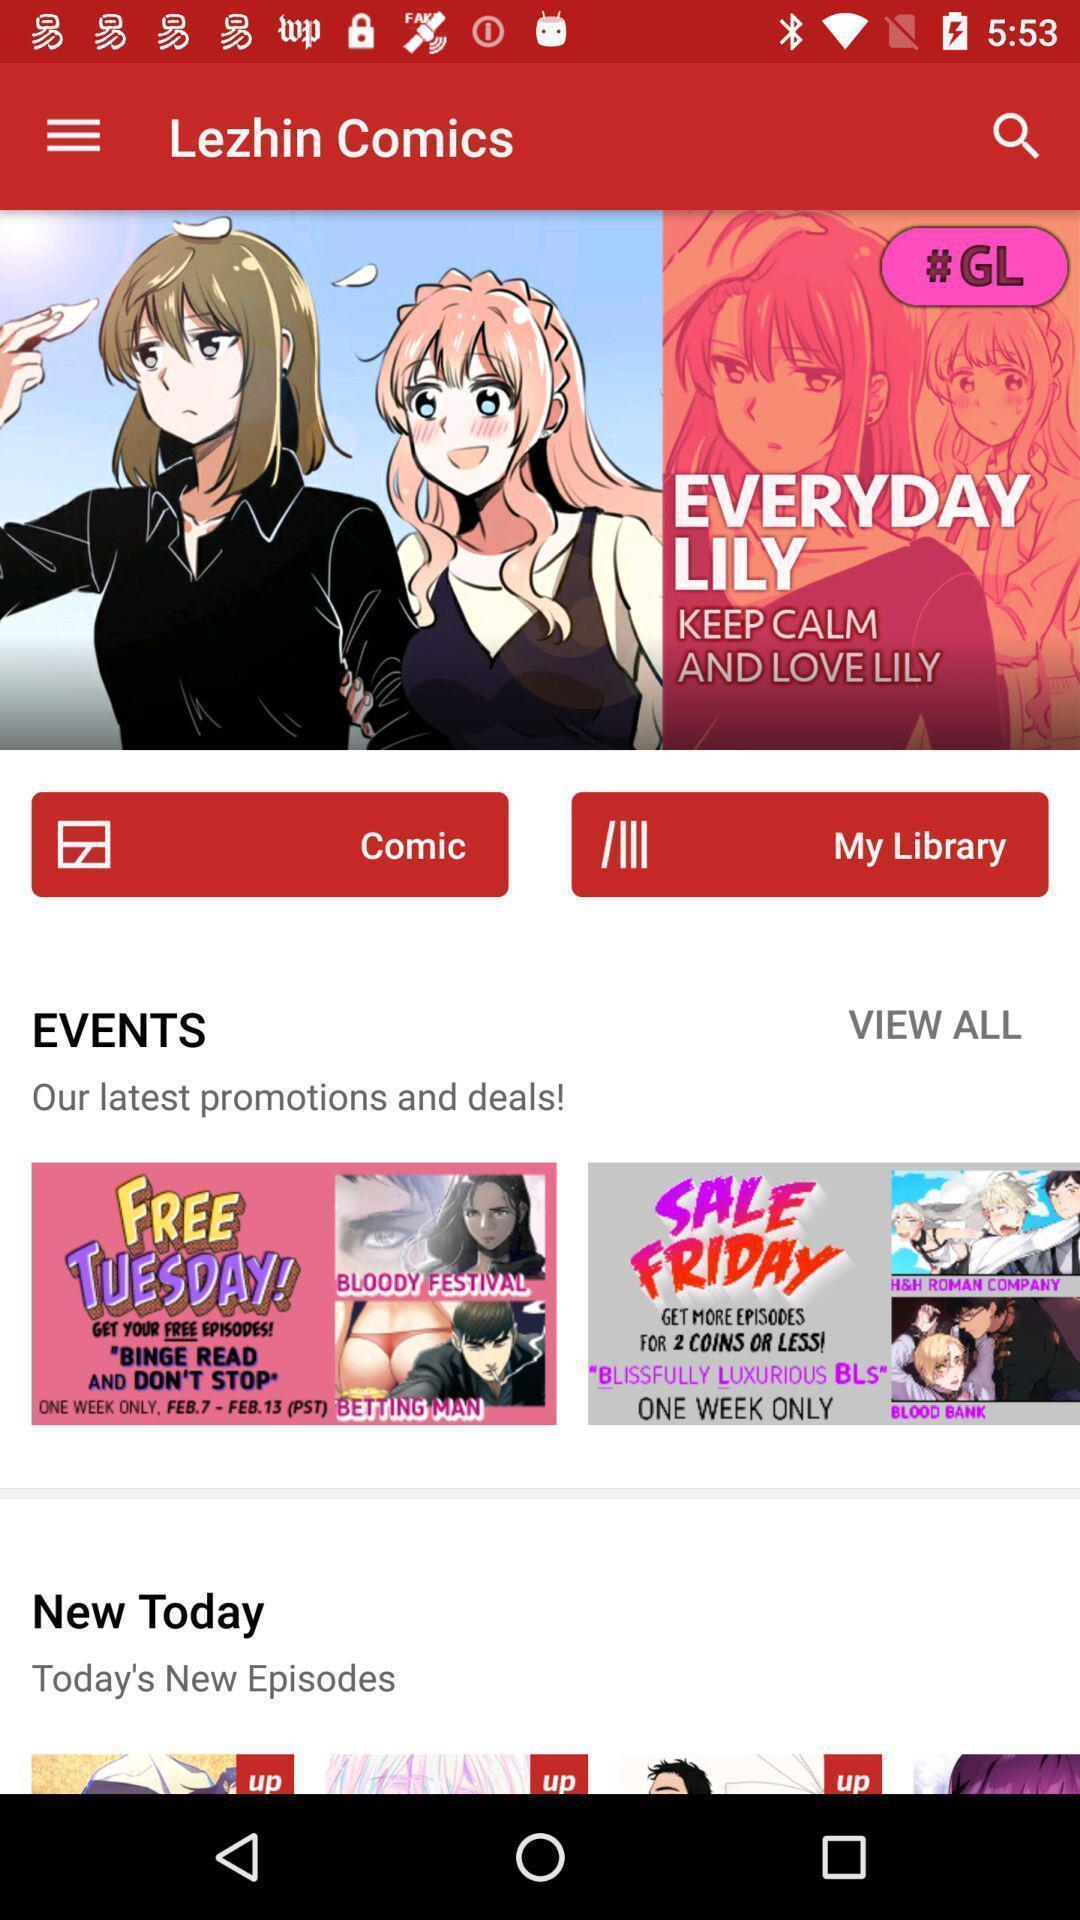Provide a textual representation of this image. Page displaying various categories. 